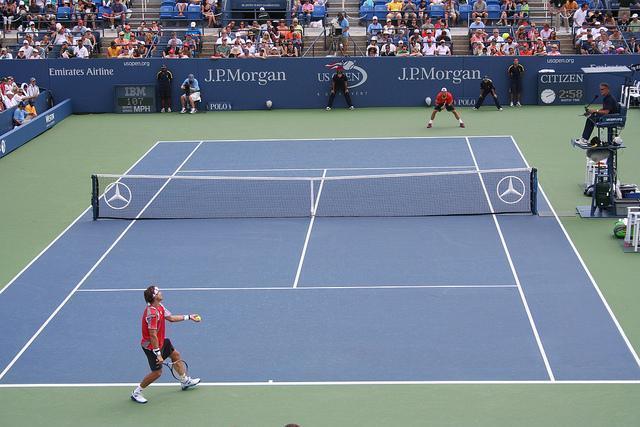How many people are in the picture?
Give a very brief answer. 2. How many red cars are in the picture?
Give a very brief answer. 0. 